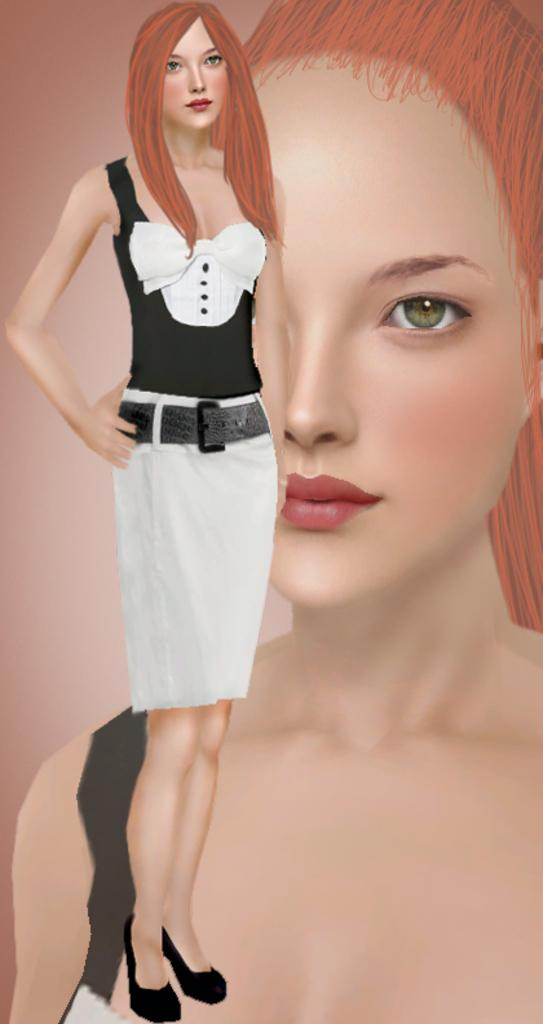What type of image is being described? The image is animated. Can you describe the woman in the image? There is a woman standing in the image. What else can be seen in the image besides the standing woman? There is an image of a woman behind the standing woman. What type of bed is visible in the image? There is no bed present in the image. What experience does the woman have in the image? The image does not provide any information about the woman's experience. 